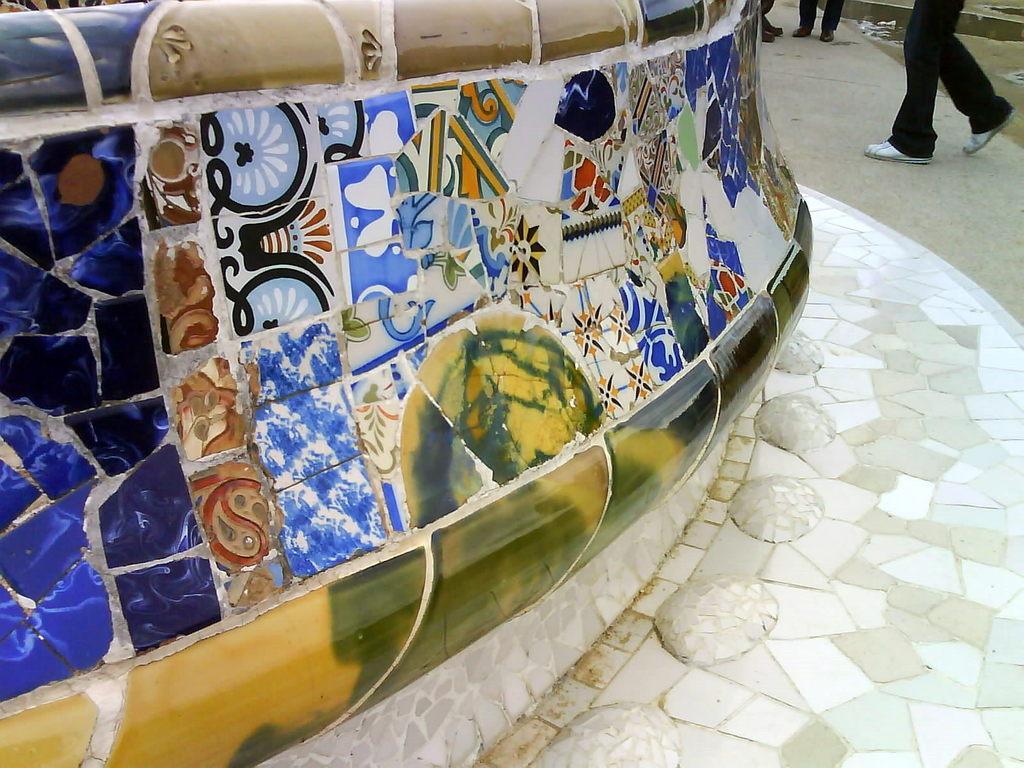Describe this image in one or two sentences. On the left side there is a wall. I can see few marbles on this wall. At the top there are few persons on the ground. 